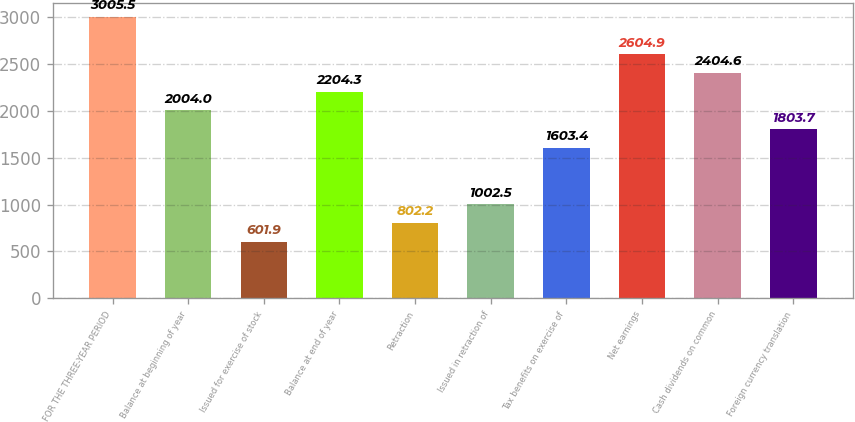<chart> <loc_0><loc_0><loc_500><loc_500><bar_chart><fcel>FOR THE THREE-YEAR PERIOD<fcel>Balance at beginning of year<fcel>Issued for exercise of stock<fcel>Balance at end of year<fcel>Retraction<fcel>Issued in retraction of<fcel>Tax benefits on exercise of<fcel>Net earnings<fcel>Cash dividends on common<fcel>Foreign currency translation<nl><fcel>3005.5<fcel>2004<fcel>601.9<fcel>2204.3<fcel>802.2<fcel>1002.5<fcel>1603.4<fcel>2604.9<fcel>2404.6<fcel>1803.7<nl></chart> 